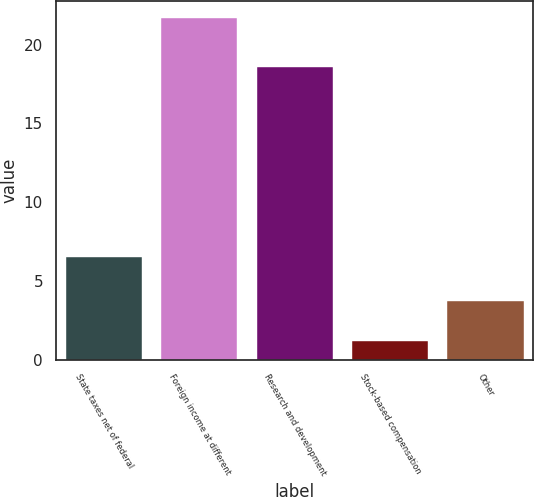Convert chart. <chart><loc_0><loc_0><loc_500><loc_500><bar_chart><fcel>State taxes net of federal<fcel>Foreign income at different<fcel>Research and development<fcel>Stock-based compensation<fcel>Other<nl><fcel>6.5<fcel>21.7<fcel>18.6<fcel>1.2<fcel>3.7<nl></chart> 